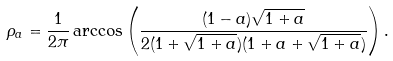Convert formula to latex. <formula><loc_0><loc_0><loc_500><loc_500>\rho _ { a } = \frac { 1 } { 2 \pi } \arccos \left ( \frac { ( 1 - a ) \sqrt { 1 + a } } { 2 ( 1 + \sqrt { 1 + a } ) ( 1 + a + \sqrt { 1 + a } ) } \right ) .</formula> 